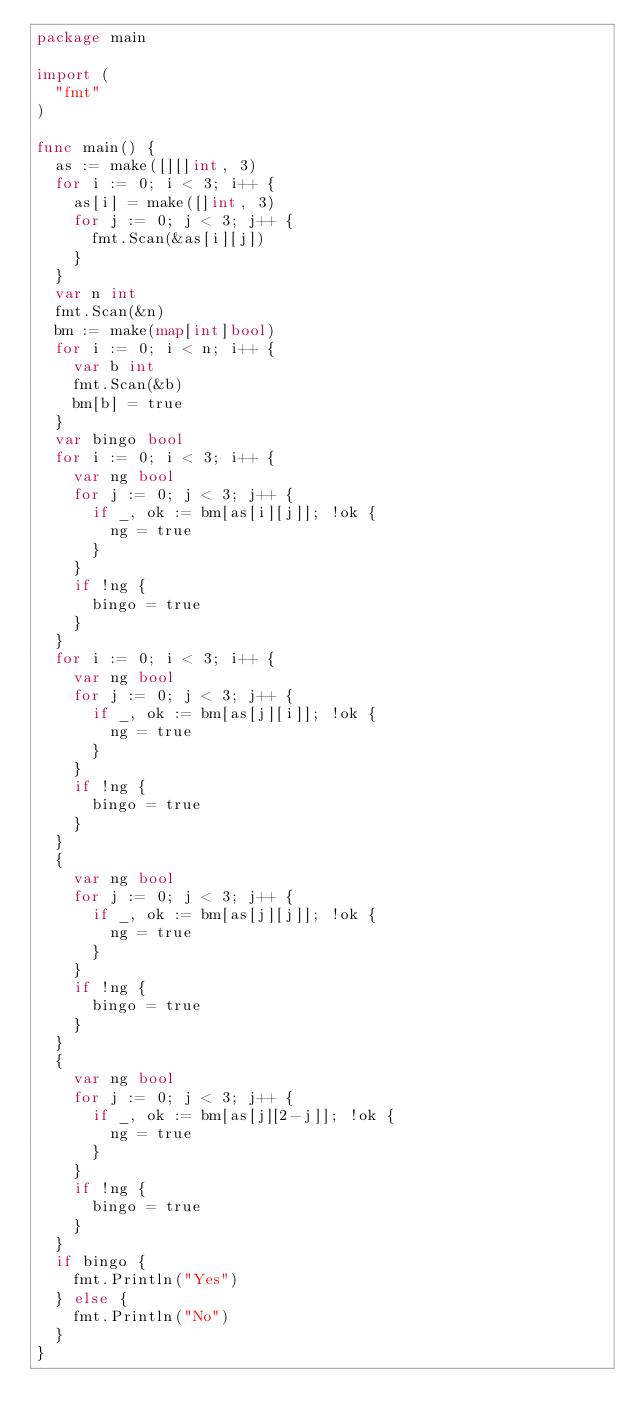Convert code to text. <code><loc_0><loc_0><loc_500><loc_500><_Go_>package main

import (
	"fmt"
)

func main() {
	as := make([][]int, 3)
	for i := 0; i < 3; i++ {
		as[i] = make([]int, 3)
		for j := 0; j < 3; j++ {
			fmt.Scan(&as[i][j])
		}
	}
	var n int
	fmt.Scan(&n)
	bm := make(map[int]bool)
	for i := 0; i < n; i++ {
		var b int
		fmt.Scan(&b)
		bm[b] = true
	}
	var bingo bool
	for i := 0; i < 3; i++ {
		var ng bool
		for j := 0; j < 3; j++ {
			if _, ok := bm[as[i][j]]; !ok {
				ng = true
			}
		}
		if !ng {
			bingo = true
		}
	}
	for i := 0; i < 3; i++ {
		var ng bool
		for j := 0; j < 3; j++ {
			if _, ok := bm[as[j][i]]; !ok {
				ng = true
			}
		}
		if !ng {
			bingo = true
		}
	}
	{
		var ng bool
		for j := 0; j < 3; j++ {
			if _, ok := bm[as[j][j]]; !ok {
				ng = true
			}
		}
		if !ng {
			bingo = true
		}
	}
	{
		var ng bool
		for j := 0; j < 3; j++ {
			if _, ok := bm[as[j][2-j]]; !ok {
				ng = true
			}
		}
		if !ng {
			bingo = true
		}
	}
	if bingo {
		fmt.Println("Yes")
	} else {
		fmt.Println("No")
	}
}
</code> 